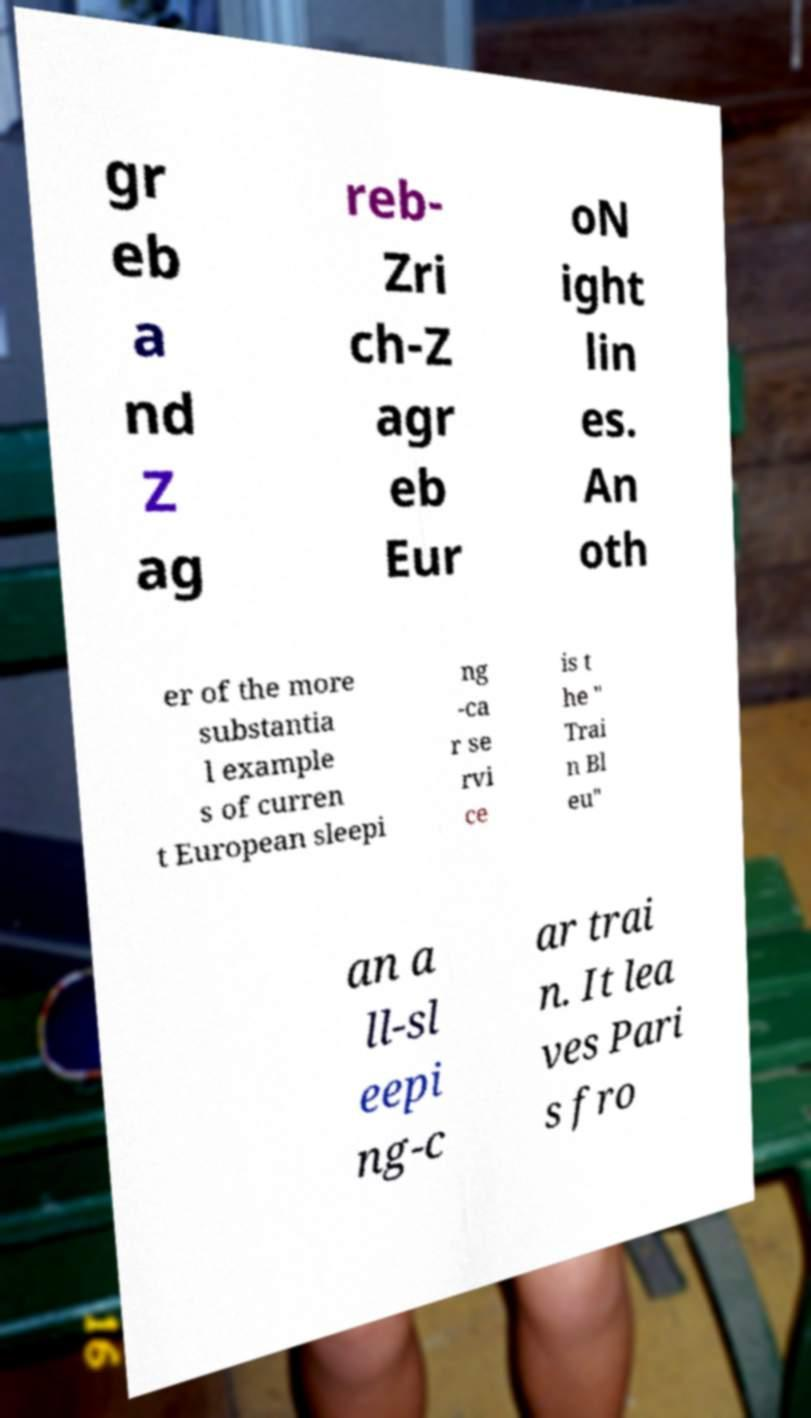There's text embedded in this image that I need extracted. Can you transcribe it verbatim? gr eb a nd Z ag reb- Zri ch-Z agr eb Eur oN ight lin es. An oth er of the more substantia l example s of curren t European sleepi ng -ca r se rvi ce is t he " Trai n Bl eu" an a ll-sl eepi ng-c ar trai n. It lea ves Pari s fro 